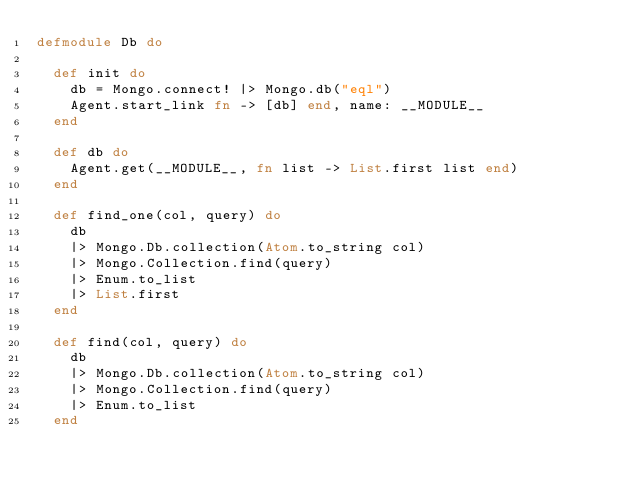<code> <loc_0><loc_0><loc_500><loc_500><_Elixir_>defmodule Db do

  def init do
    db = Mongo.connect! |> Mongo.db("eql")
    Agent.start_link fn -> [db] end, name: __MODULE__
  end

  def db do
    Agent.get(__MODULE__, fn list -> List.first list end)
  end

  def find_one(col, query) do
    db
    |> Mongo.Db.collection(Atom.to_string col)
    |> Mongo.Collection.find(query)
    |> Enum.to_list
    |> List.first
  end

  def find(col, query) do
    db
    |> Mongo.Db.collection(Atom.to_string col)
    |> Mongo.Collection.find(query)
    |> Enum.to_list
  end
</code> 